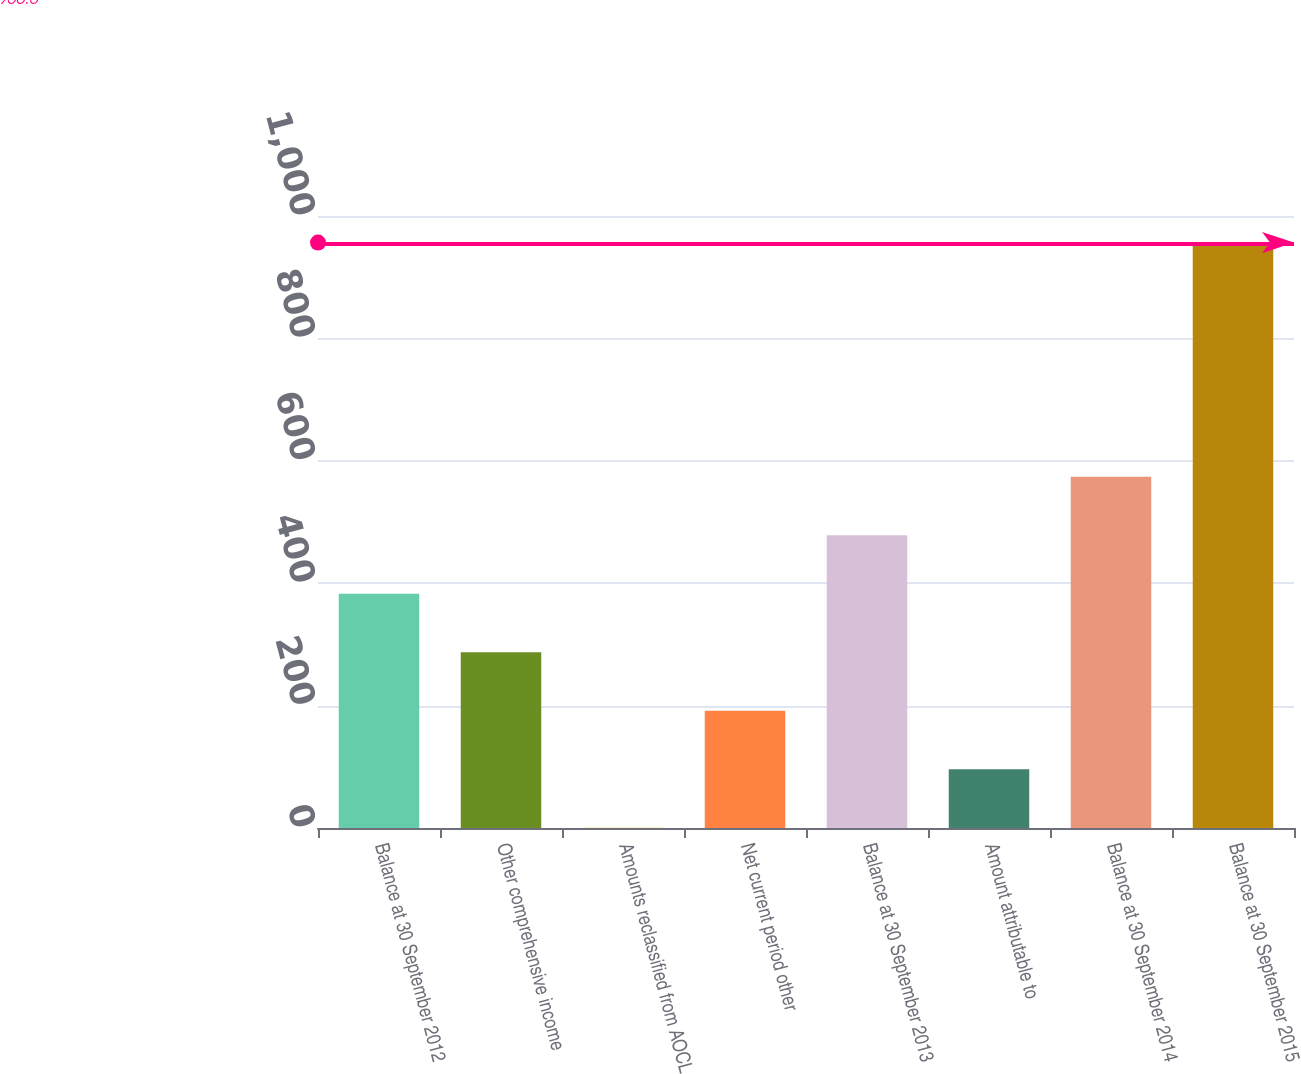<chart> <loc_0><loc_0><loc_500><loc_500><bar_chart><fcel>Balance at 30 September 2012<fcel>Other comprehensive income<fcel>Amounts reclassified from AOCL<fcel>Net current period other<fcel>Balance at 30 September 2013<fcel>Amount attributable to<fcel>Balance at 30 September 2014<fcel>Balance at 30 September 2015<nl><fcel>382.96<fcel>287.37<fcel>0.6<fcel>191.78<fcel>478.55<fcel>96.19<fcel>574.14<fcel>956.5<nl></chart> 